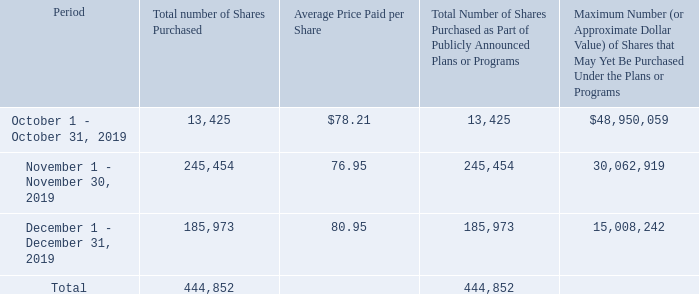In the following table, we provide information regarding our common stock repurchases under our publicly-announced share repurchase program for the quarter ended December 31, 2019. All repurchases related to the share repurchase program were made on
the open market.
During the year ended December 31, 2019, we repurchased a total of 1,640,055 shares at an average price per share of $70.65 under our publicly-announced share repurchase program. In January 2020, our Board of Directors authorized the Company to repurchase up to an aggregate of $50 million of the Company’s common stock.
How many shares are repurchased in 2019 October? 13,425. What is the average repurchase price paid per share for 2019 December? 80.95. What is the amount of share repurchase authorised by the board of directors in Janurary 2020? $50 million. What is the amount of money used for share repurchase in 2019 October? 13,425*$78.21
Answer: 1049969.25. Which period has the highest total number of shares purchased? 245,454> 185,973> 13,425
Answer: november 1 - november 30, 2019. What is the difference in the total number of shares purchased between November and December? 245,454-185,973
Answer: 59481. 